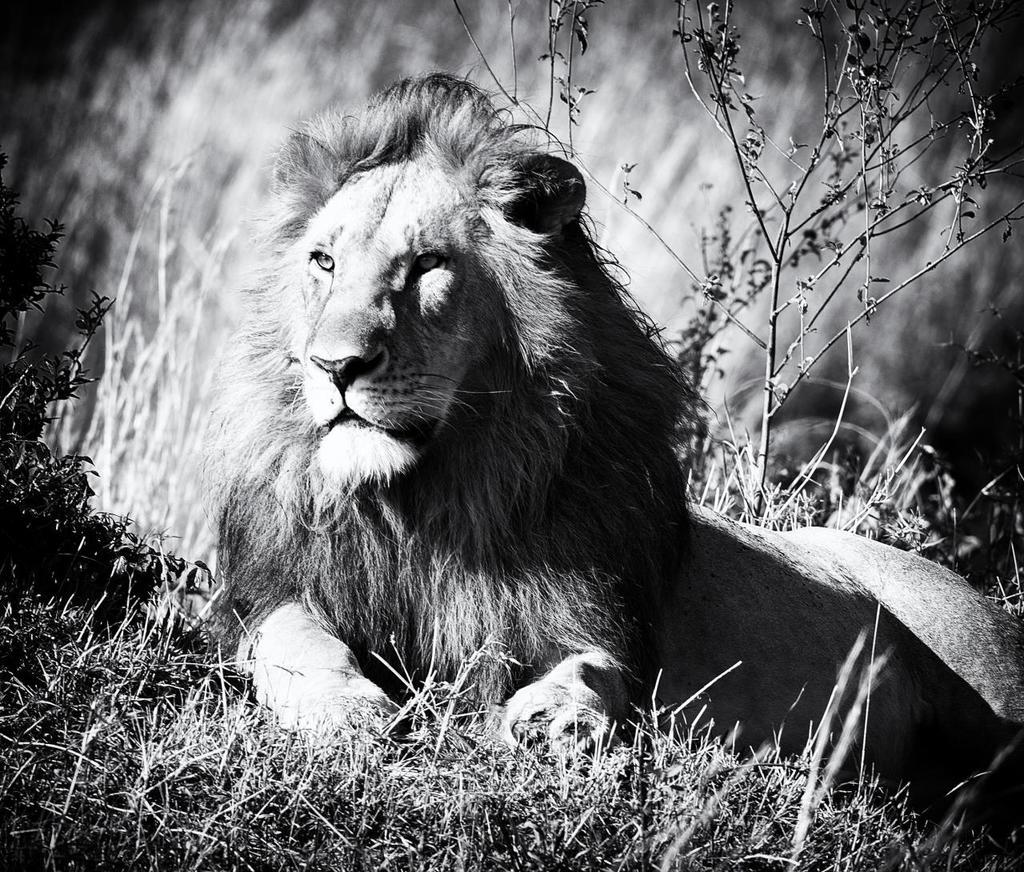What is the main subject in the center of the image? There is a lion in the center of the image. What type of vegetation is present at the bottom of the image? Grass is present at the bottom of the image. What can be seen in the background of the image? Small plants are visible in the background of the image. How many fingers does the lion have in the image? Lions do not have fingers; they have paws with claws. The image does not show the lion's paws in detail, but it is clear that the lion has paws, not fingers. 